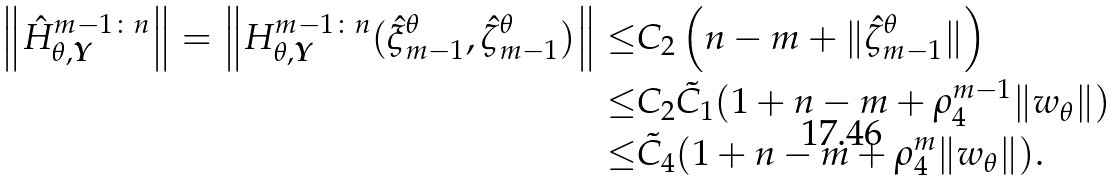Convert formula to latex. <formula><loc_0><loc_0><loc_500><loc_500>\left \| \hat { H } _ { \theta , \boldsymbol Y } ^ { m - 1 \colon n } \right \| = \left \| H _ { \theta , \boldsymbol Y } ^ { m - 1 \colon n } ( \hat { \xi } _ { m - 1 } ^ { \theta } , \hat { \zeta } _ { m - 1 } ^ { \theta } ) \right \| \leq & C _ { 2 } \left ( n - m + \| \hat { \zeta } _ { m - 1 } ^ { \theta } \| \right ) \\ \leq & C _ { 2 } \tilde { C } _ { 1 } ( 1 + n - m + \rho _ { 4 } ^ { m - 1 } \| w _ { \theta } \| ) \\ \leq & \tilde { C } _ { 4 } ( 1 + n - m + \rho _ { 4 } ^ { m } \| w _ { \theta } \| ) .</formula> 